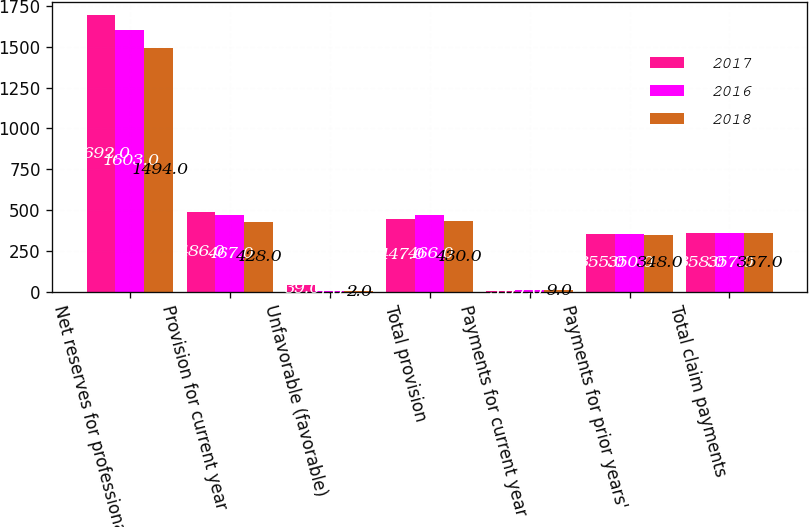Convert chart to OTSL. <chart><loc_0><loc_0><loc_500><loc_500><stacked_bar_chart><ecel><fcel>Net reserves for professional<fcel>Provision for current year<fcel>Unfavorable (favorable)<fcel>Total provision<fcel>Payments for current year<fcel>Payments for prior years'<fcel>Total claim payments<nl><fcel>2017<fcel>1692<fcel>486<fcel>39<fcel>447<fcel>3<fcel>355<fcel>358<nl><fcel>2016<fcel>1603<fcel>467<fcel>1<fcel>466<fcel>7<fcel>350<fcel>357<nl><fcel>2018<fcel>1494<fcel>428<fcel>2<fcel>430<fcel>9<fcel>348<fcel>357<nl></chart> 